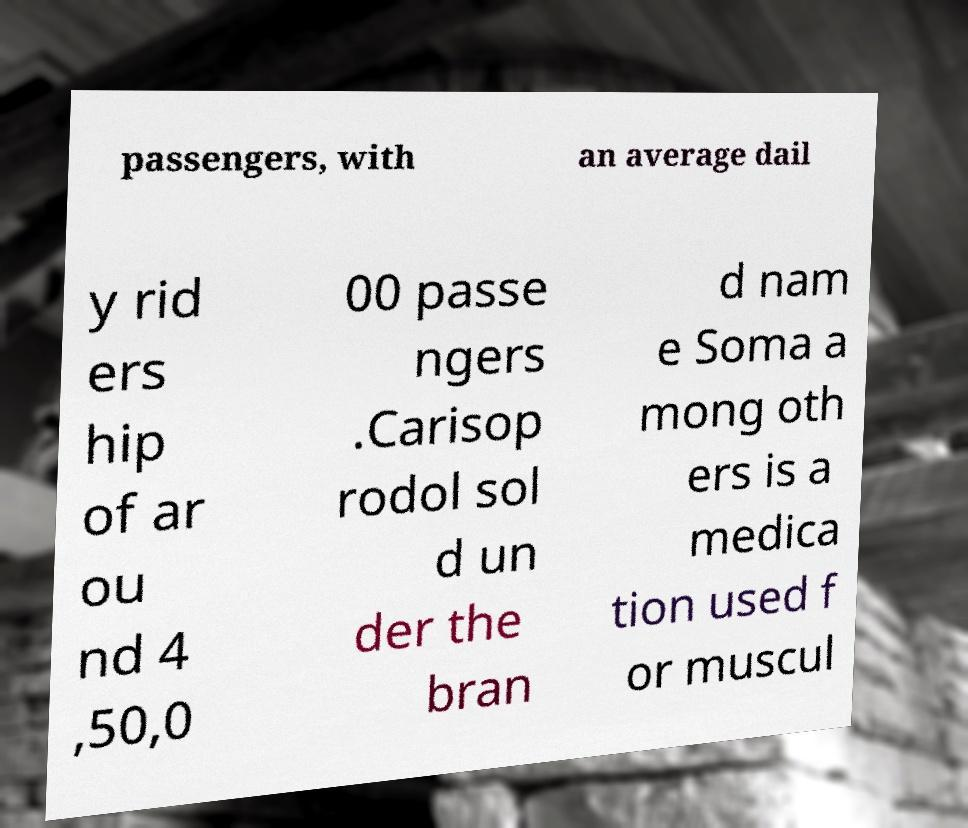Please read and relay the text visible in this image. What does it say? passengers, with an average dail y rid ers hip of ar ou nd 4 ,50,0 00 passe ngers .Carisop rodol sol d un der the bran d nam e Soma a mong oth ers is a medica tion used f or muscul 